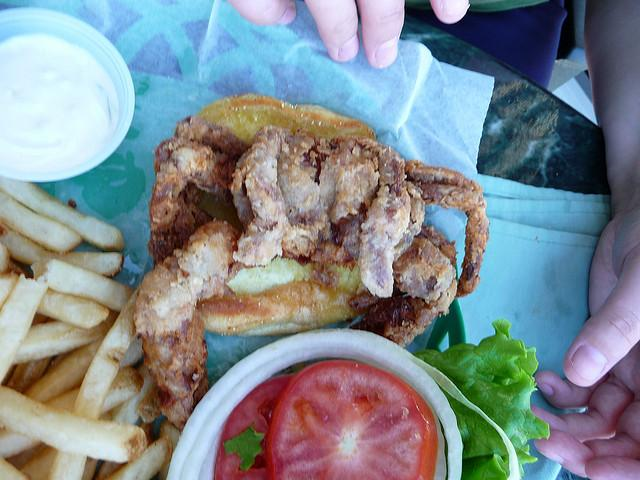What is being dissected here? sandwich 